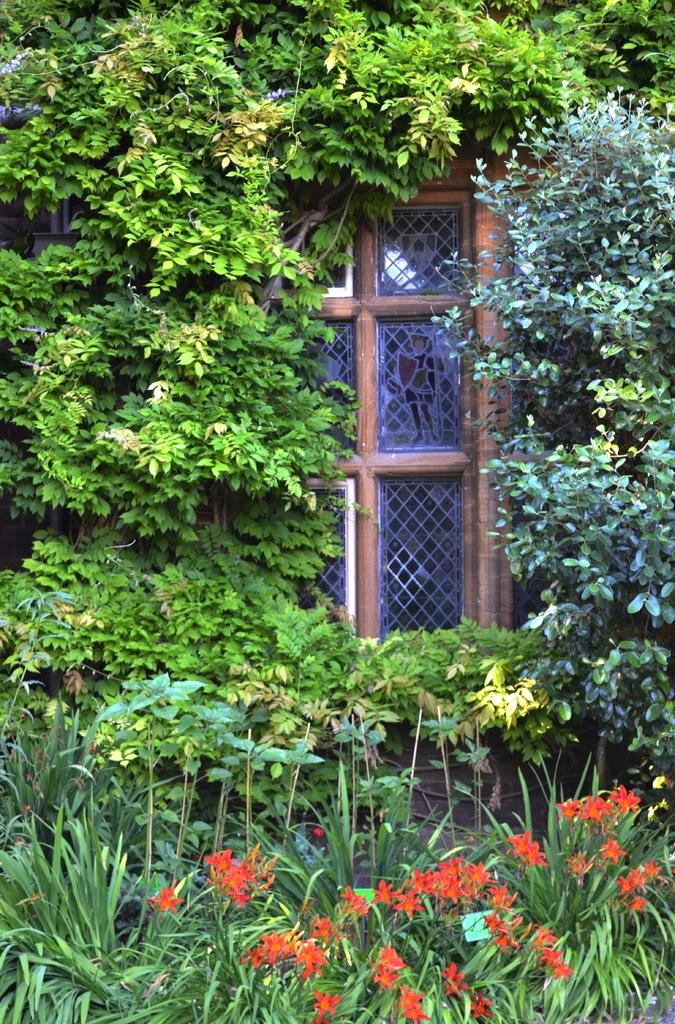What color are the flowers in the image? The flowers in the image are orange. What can be seen in the background of the image? The background of the image includes plants and trees in green color. Can you describe the door in the image? There is a door in brown color in the image. How many friends are visible in the image? There are no friends present in the image; it features flowers, plants, trees, and a door. What type of industry is depicted in the image? There is no industry depicted in the image; it is a nature scene with flowers, plants, trees, and a door. 